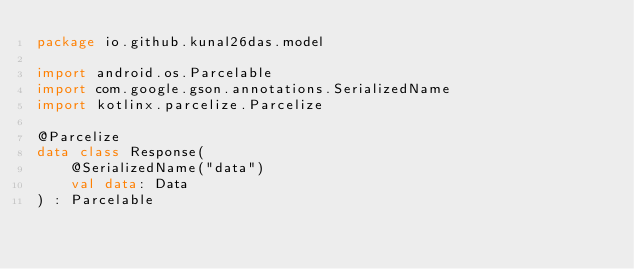<code> <loc_0><loc_0><loc_500><loc_500><_Kotlin_>package io.github.kunal26das.model

import android.os.Parcelable
import com.google.gson.annotations.SerializedName
import kotlinx.parcelize.Parcelize

@Parcelize
data class Response(
    @SerializedName("data")
    val data: Data
) : Parcelable</code> 